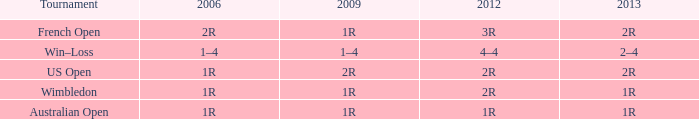What shows for 2013 when the 2012 is 2r, and a 2009 is 2r? 2R. 